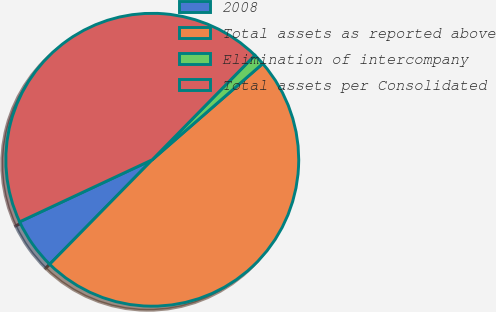Convert chart. <chart><loc_0><loc_0><loc_500><loc_500><pie_chart><fcel>2008<fcel>Total assets as reported above<fcel>Elimination of intercompany<fcel>Total assets per Consolidated<nl><fcel>5.68%<fcel>48.75%<fcel>1.25%<fcel>44.32%<nl></chart> 